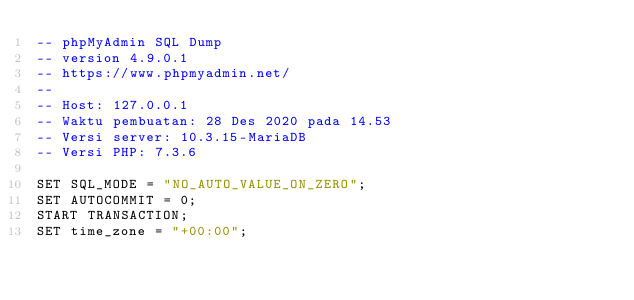Convert code to text. <code><loc_0><loc_0><loc_500><loc_500><_SQL_>-- phpMyAdmin SQL Dump
-- version 4.9.0.1
-- https://www.phpmyadmin.net/
--
-- Host: 127.0.0.1
-- Waktu pembuatan: 28 Des 2020 pada 14.53
-- Versi server: 10.3.15-MariaDB
-- Versi PHP: 7.3.6

SET SQL_MODE = "NO_AUTO_VALUE_ON_ZERO";
SET AUTOCOMMIT = 0;
START TRANSACTION;
SET time_zone = "+00:00";

</code> 